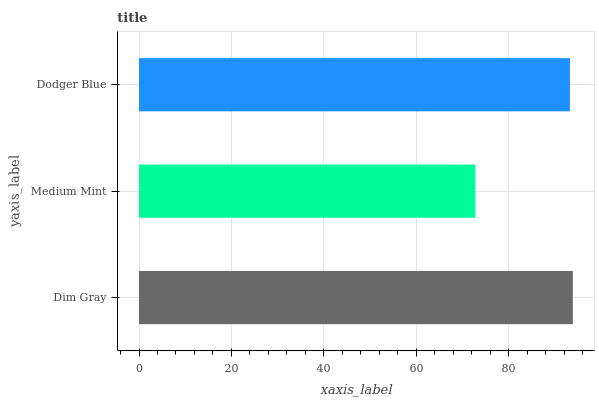Is Medium Mint the minimum?
Answer yes or no. Yes. Is Dim Gray the maximum?
Answer yes or no. Yes. Is Dodger Blue the minimum?
Answer yes or no. No. Is Dodger Blue the maximum?
Answer yes or no. No. Is Dodger Blue greater than Medium Mint?
Answer yes or no. Yes. Is Medium Mint less than Dodger Blue?
Answer yes or no. Yes. Is Medium Mint greater than Dodger Blue?
Answer yes or no. No. Is Dodger Blue less than Medium Mint?
Answer yes or no. No. Is Dodger Blue the high median?
Answer yes or no. Yes. Is Dodger Blue the low median?
Answer yes or no. Yes. Is Medium Mint the high median?
Answer yes or no. No. Is Medium Mint the low median?
Answer yes or no. No. 